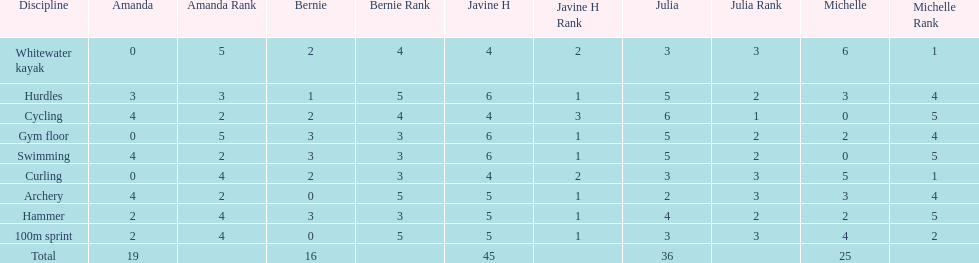What other girl besides amanda also had a 4 in cycling? Javine H. 